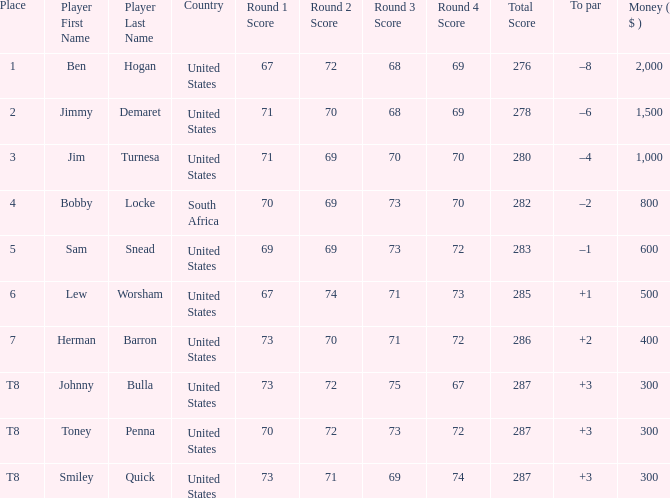Give me the full table as a dictionary. {'header': ['Place', 'Player First Name', 'Player Last Name', 'Country', 'Round 1 Score', 'Round 2 Score', 'Round 3 Score', 'Round 4 Score', 'Total Score', 'To par', 'Money ( $ )'], 'rows': [['1', 'Ben', 'Hogan', 'United States', '67', '72', '68', '69', '276', '–8', '2,000'], ['2', 'Jimmy', 'Demaret', 'United States', '71', '70', '68', '69', '278', '–6', '1,500'], ['3', 'Jim', 'Turnesa', 'United States', '71', '69', '70', '70', '280', '–4', '1,000'], ['4', 'Bobby', 'Locke', 'South Africa', '70', '69', '73', '70', '282', '–2', '800'], ['5', 'Sam', 'Snead', 'United States', '69', '69', '73', '72', '283', '–1', '600'], ['6', 'Lew', 'Worsham', 'United States', '67', '74', '71', '73', '285', '+1', '500'], ['7', 'Herman', 'Barron', 'United States', '73', '70', '71', '72', '286', '+2', '400'], ['T8', 'Johnny', 'Bulla', 'United States', '73', '72', '75', '67', '287', '+3', '300'], ['T8', 'Toney', 'Penna', 'United States', '70', '72', '73', '72', '287', '+3', '300'], ['T8', 'Smiley', 'Quick', 'United States', '73', '71', '69', '74', '287', '+3', '300']]} What is the Money of the Player in Place 5? 600.0. 